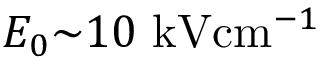Convert formula to latex. <formula><loc_0><loc_0><loc_500><loc_500>E _ { 0 } { \sim } 1 0 { k V c m ^ { - 1 } }</formula> 